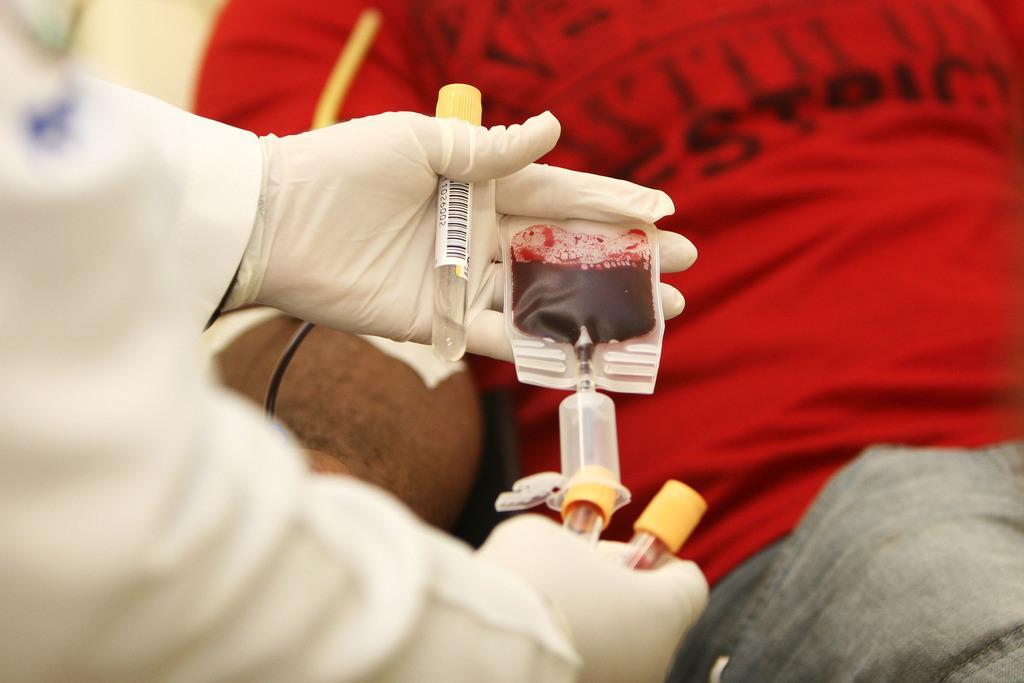Could you give a brief overview of what you see in this image? In this image we can see a blood packet, small tubes in the person's hand, there we can see the blood is taken from the other person. 